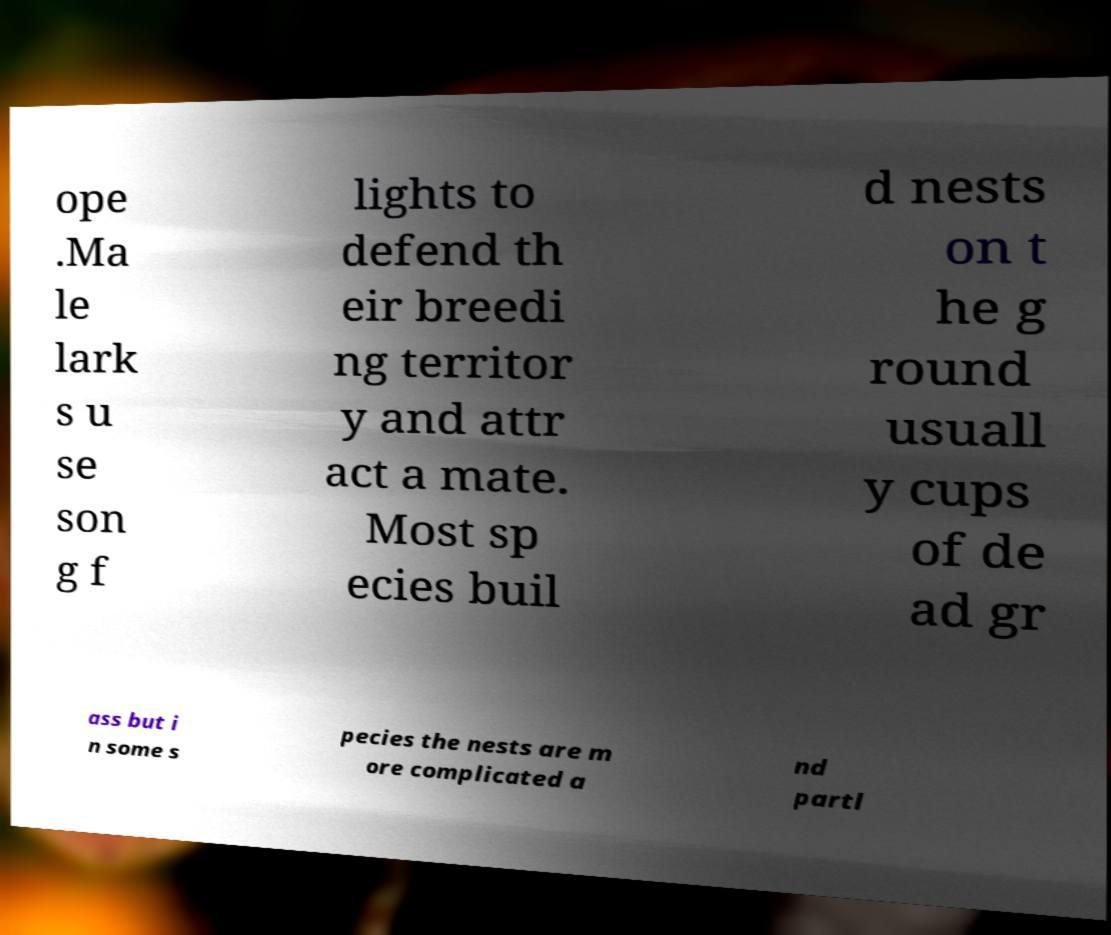Please read and relay the text visible in this image. What does it say? ope .Ma le lark s u se son g f lights to defend th eir breedi ng territor y and attr act a mate. Most sp ecies buil d nests on t he g round usuall y cups of de ad gr ass but i n some s pecies the nests are m ore complicated a nd partl 